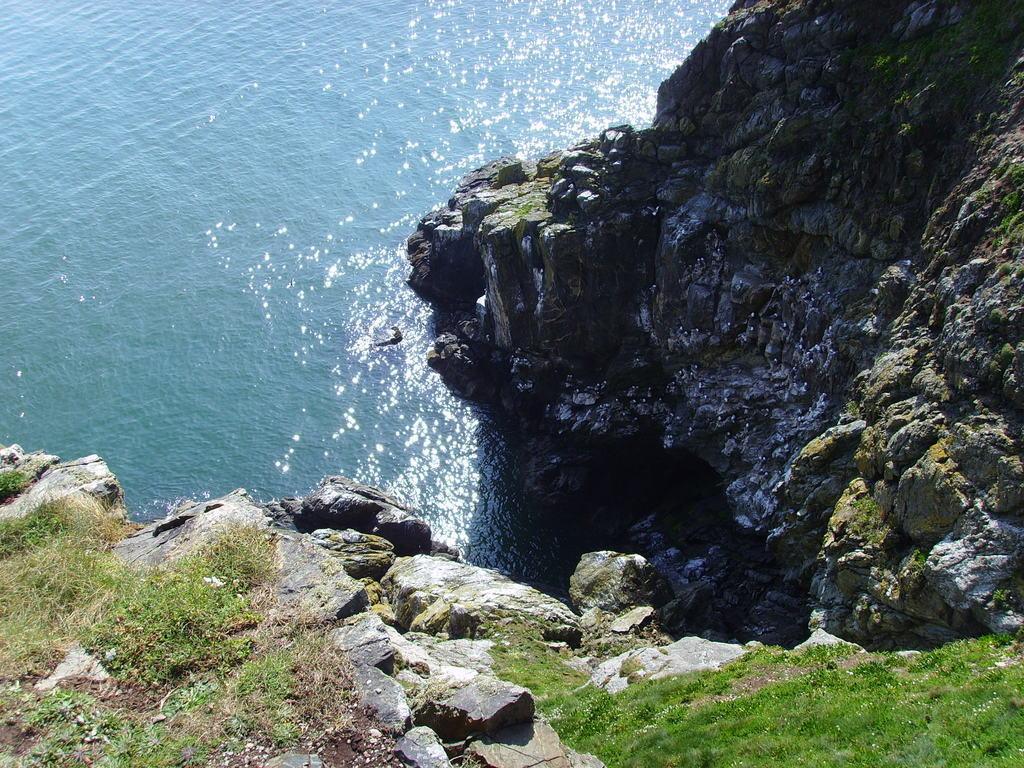How would you summarize this image in a sentence or two? In the image in the center, we can see water, hills and grass. 